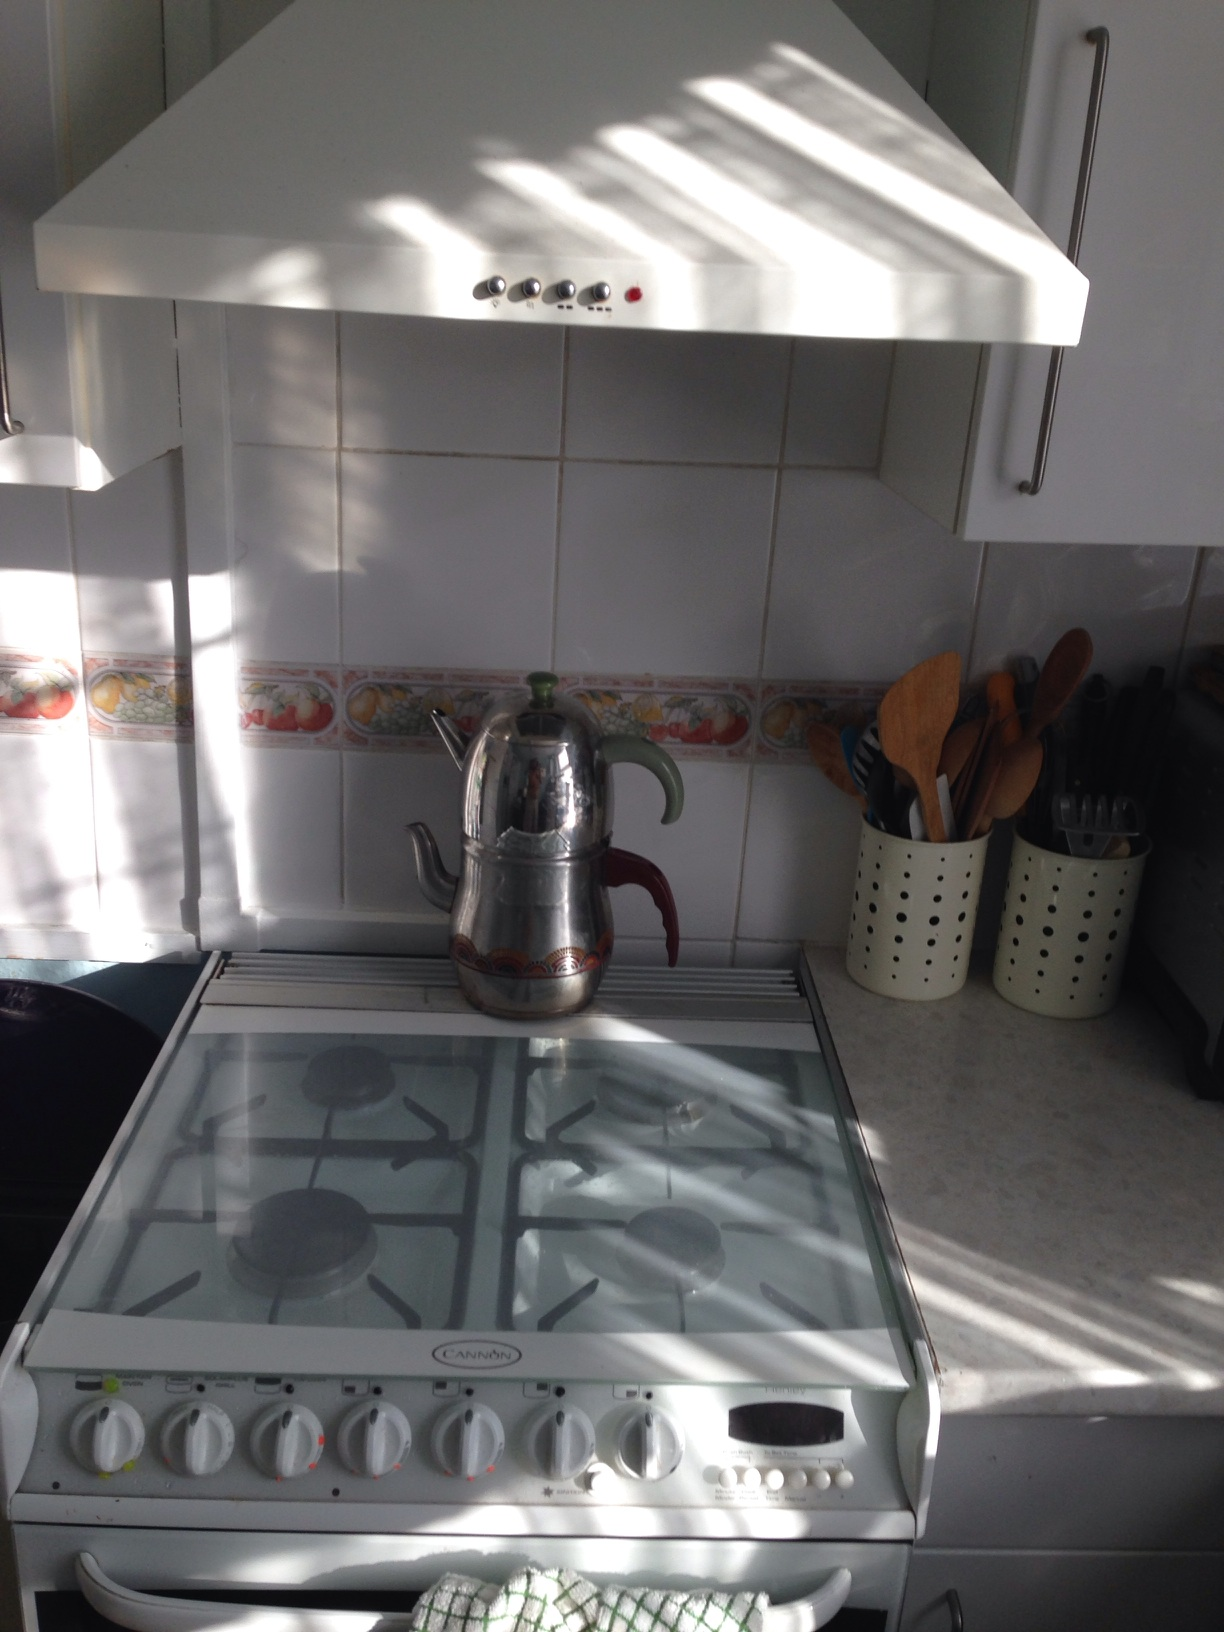What's a realistic scenario of someone using this kitchen for a longer duration? In a longer duration scenario, someone might be preparing an elaborate meal for a family dinner. They could be using the different burners to cook multiple dishes simultaneously — a pot of hearty soup on one burner, a pan of sauteed vegetables on another, and perhaps a sauce simmering on a third. The utensils within easy reach will be used to stir, flip, and mix the various ingredients. The cook might also periodically boil water in the teapot for tea to serve later. The kitchen would be filled with the fragrant aroma of different dishes, creating a homey and inviting atmosphere. 